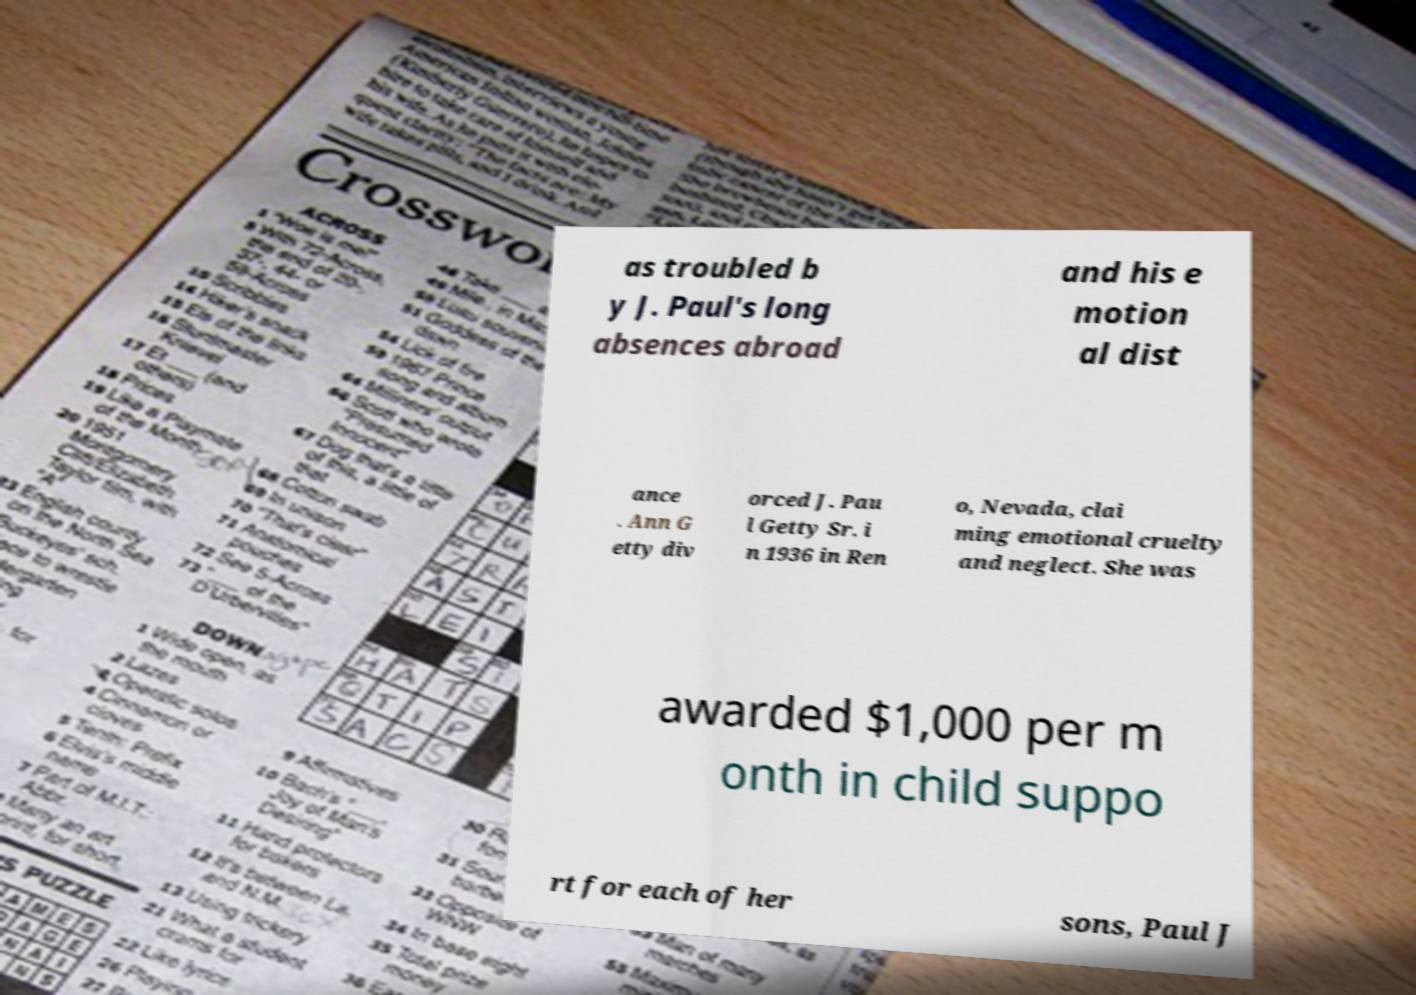Can you accurately transcribe the text from the provided image for me? as troubled b y J. Paul's long absences abroad and his e motion al dist ance . Ann G etty div orced J. Pau l Getty Sr. i n 1936 in Ren o, Nevada, clai ming emotional cruelty and neglect. She was awarded $1,000 per m onth in child suppo rt for each of her sons, Paul J 